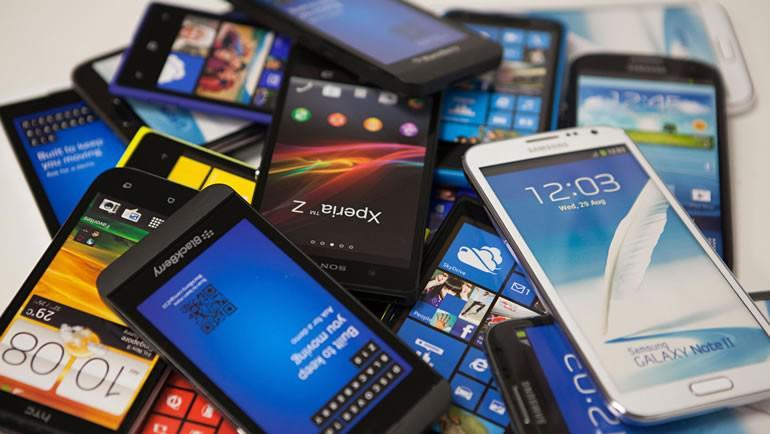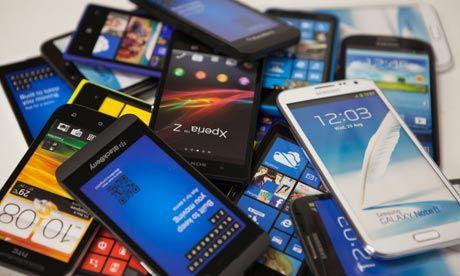The first image is the image on the left, the second image is the image on the right. Analyze the images presented: Is the assertion "No image contains more than 9 screened devices, and one image shows multiple devices in a straight row." valid? Answer yes or no. No. 